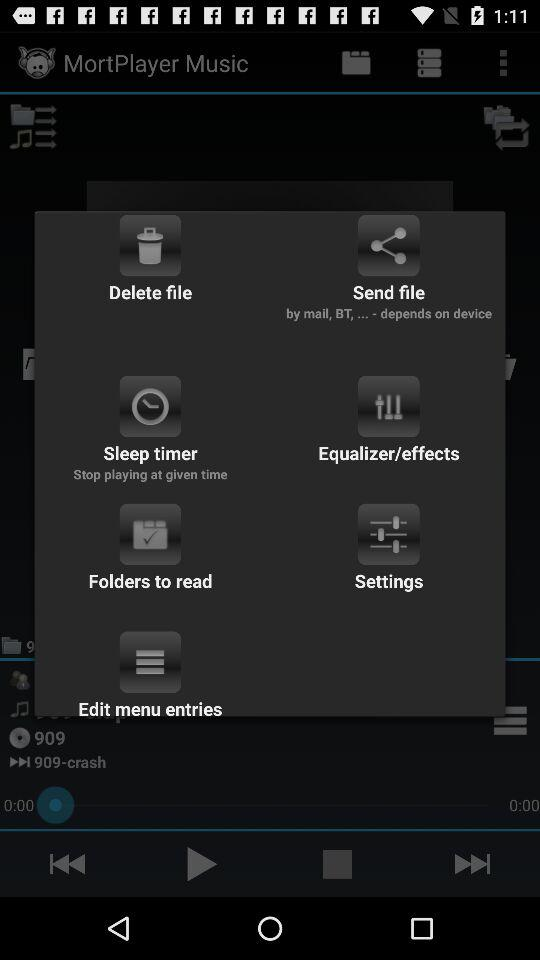Which item in the first row is the longest in terms of text?
Answer the question using a single word or phrase. Send file 